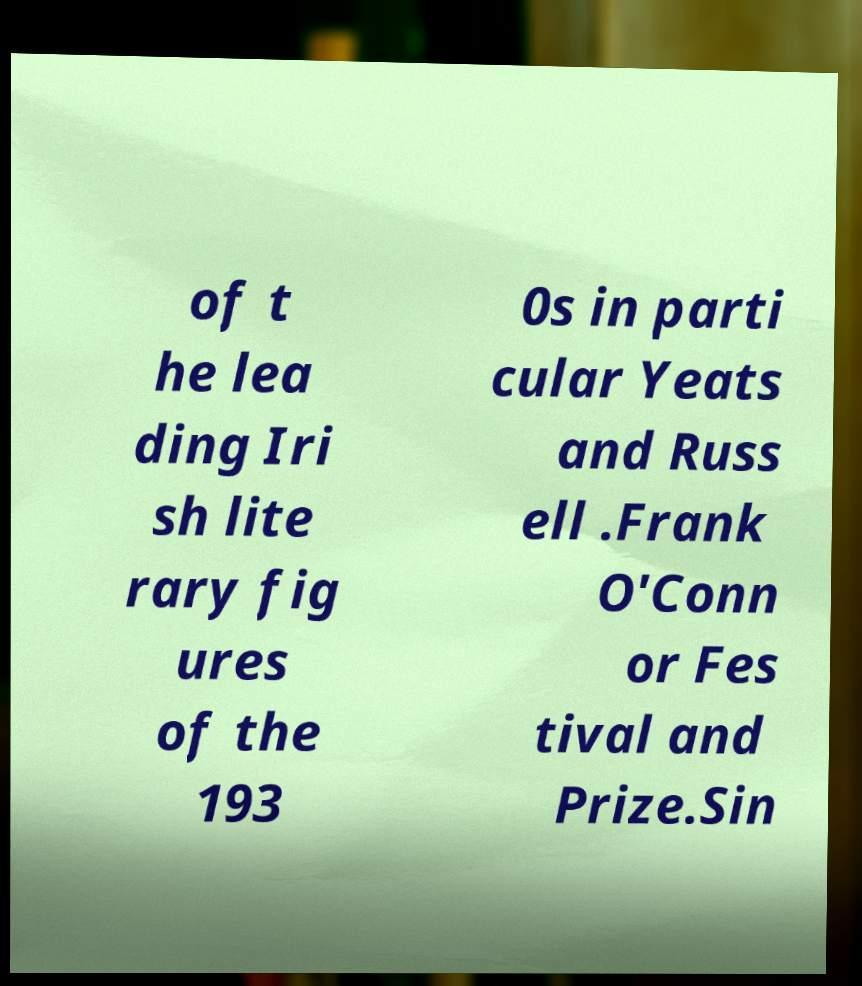Please identify and transcribe the text found in this image. of t he lea ding Iri sh lite rary fig ures of the 193 0s in parti cular Yeats and Russ ell .Frank O'Conn or Fes tival and Prize.Sin 